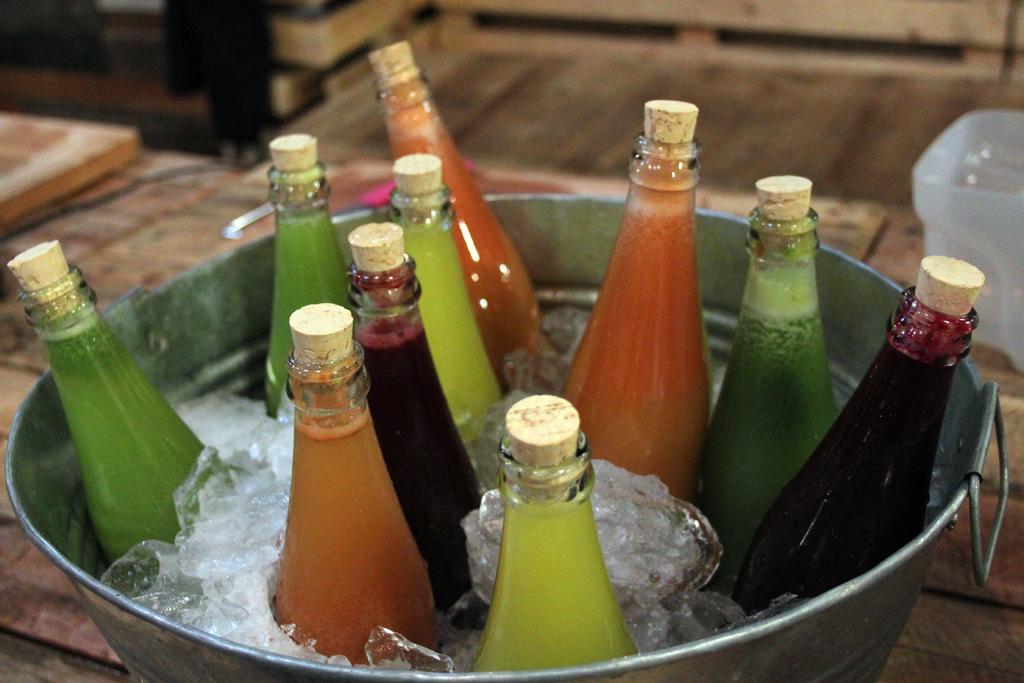Could you give a brief overview of what you see in this image? In this picture there is a container in which there are different types of juice bottles, which are placed with the ice and there is a table around the area of the image, the bottles are in different color. 